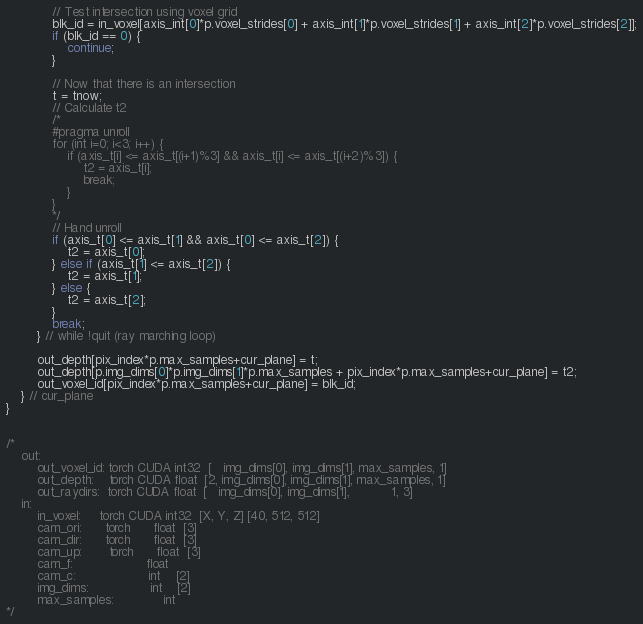Convert code to text. <code><loc_0><loc_0><loc_500><loc_500><_Cuda_>
            // Test intersection using voxel grid
            blk_id = in_voxel[axis_int[0]*p.voxel_strides[0] + axis_int[1]*p.voxel_strides[1] + axis_int[2]*p.voxel_strides[2]];
            if (blk_id == 0) {
                continue;
            }

            // Now that there is an intersection
            t = tnow;
            // Calculate t2
            /*
            #pragma unroll
            for (int i=0; i<3; i++) {
                if (axis_t[i] <= axis_t[(i+1)%3] && axis_t[i] <= axis_t[(i+2)%3]) {
                    t2 = axis_t[i];
                    break;
                }
            }
            */
            // Hand unroll
            if (axis_t[0] <= axis_t[1] && axis_t[0] <= axis_t[2]) {
                t2 = axis_t[0];
            } else if (axis_t[1] <= axis_t[2]) {
                t2 = axis_t[1];
            } else {
                t2 = axis_t[2];
            }
            break;
        } // while !quit (ray marching loop)

        out_depth[pix_index*p.max_samples+cur_plane] = t;
        out_depth[p.img_dims[0]*p.img_dims[1]*p.max_samples + pix_index*p.max_samples+cur_plane] = t2;
        out_voxel_id[pix_index*p.max_samples+cur_plane] = blk_id;
    } // cur_plane
}


/*
    out:
        out_voxel_id: torch CUDA int32  [   img_dims[0], img_dims[1], max_samples, 1]
        out_depth:    torch CUDA float  [2, img_dims[0], img_dims[1], max_samples, 1]
        out_raydirs:  torch CUDA float  [   img_dims[0], img_dims[1],           1, 3]
    in:
        in_voxel:     torch CUDA int32  [X, Y, Z] [40, 512, 512]
        cam_ori:      torch      float  [3]
        cam_dir:      torch      float  [3]
        cam_up:       torch      float  [3]
        cam_f:                   float
        cam_c:                   int    [2]
        img_dims:                int    [2]
        max_samples:             int
*/</code> 